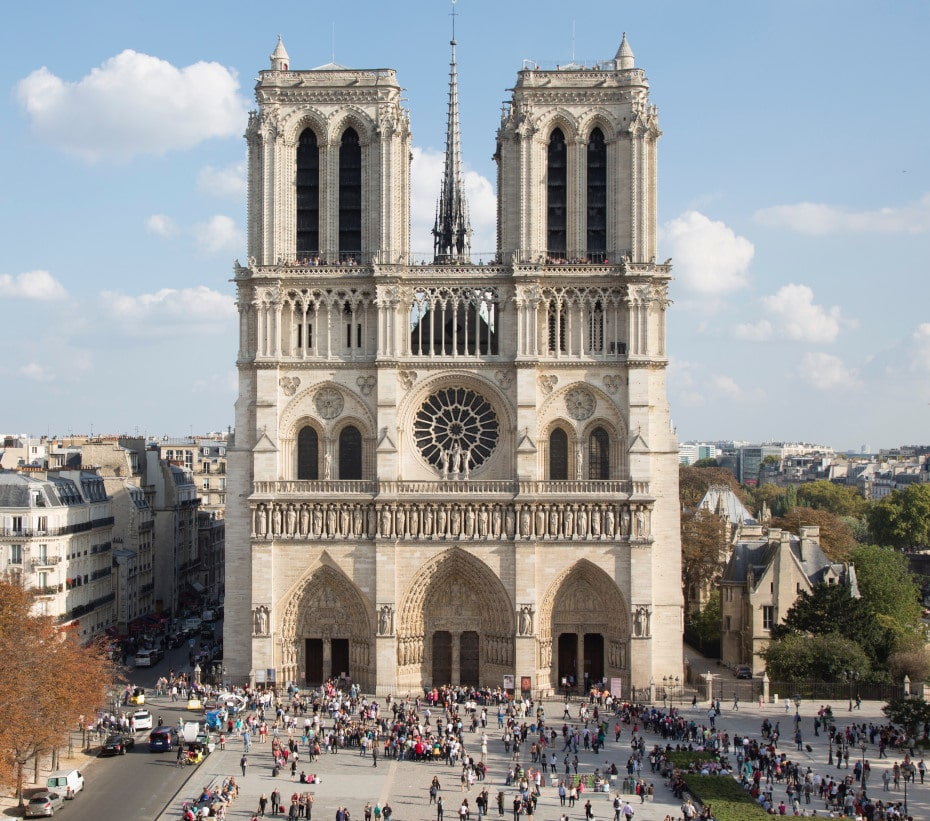Analyze the image in a comprehensive and detailed manner. The image depicts the iconic Notre Dame Cathedral in Paris, France, showcasing the grandeur of French Gothic architecture. Taken from an elevated vantage point, the photograph provides an expansive view of the cathedral's intricate design and its surrounding environment.

The facade is constructed from light-colored stone, giving it a regal and timeless appearance. The central entrance is flanked by two towering structures, each adorned with arched windows that culminate in pointed spires, reinforcing the vertical emphasis characteristic of Gothic architecture. A large and ornamental rose window dominates the center of the facade, a key feature in Gothic cathedrals, and above it, a tall spire extends further skyward.

The context reveals Notre Dame situated amid a busy urban setting, with trees and buildings surrounding it, marking its central location in the city of Paris. In front of the cathedral, the plaza is bustling with people, injecting the scene with life and offering a snapshot of the vibrant activity typical of this historic landmark. The image beautifully balances the architectural majesty of Notre Dame with the everyday vibrancy of its urban surroundings. 